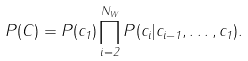<formula> <loc_0><loc_0><loc_500><loc_500>P ( { C } ) = P ( c _ { 1 } ) \prod _ { i = 2 } ^ { N _ { W } } P ( c _ { i } | c _ { i - 1 } , \dots , c _ { 1 } ) .</formula> 